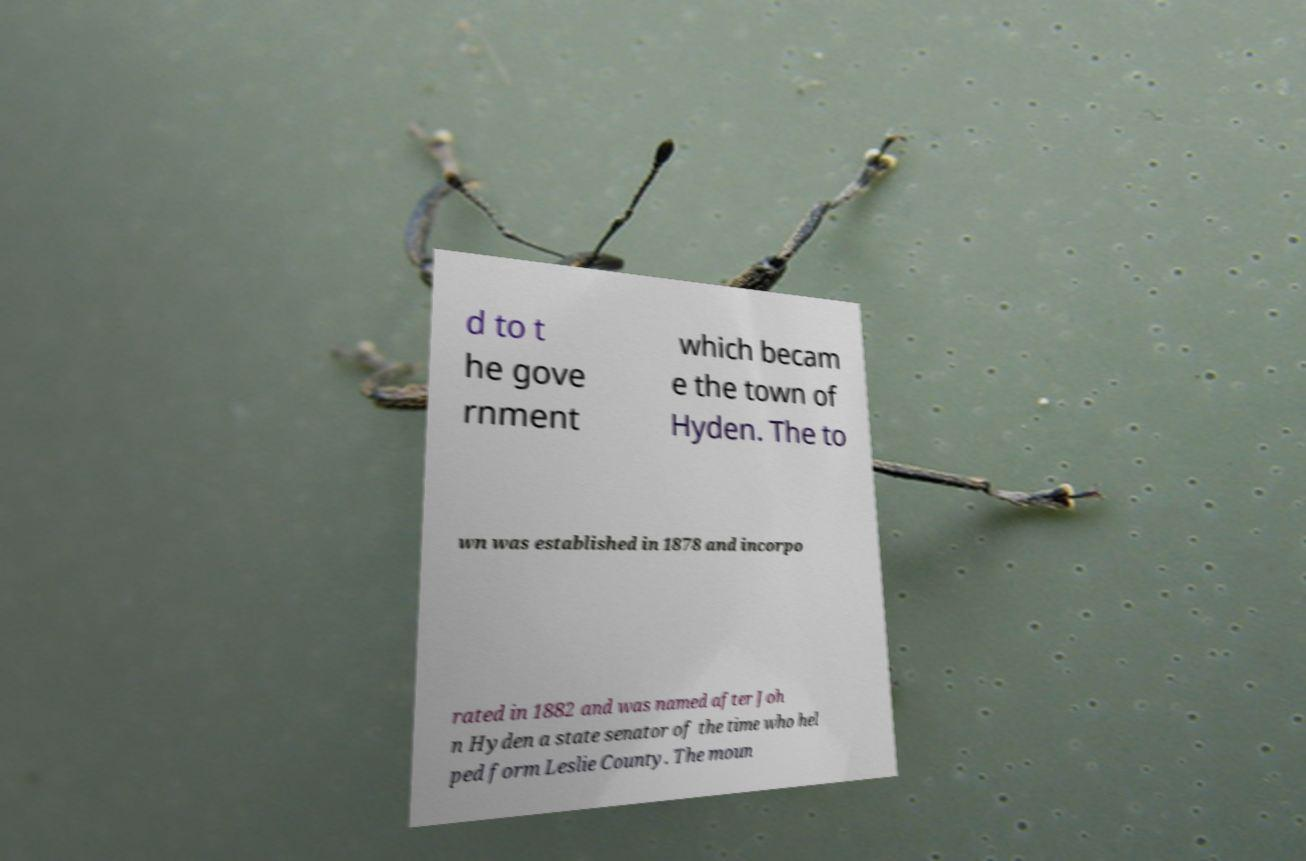Please read and relay the text visible in this image. What does it say? d to t he gove rnment which becam e the town of Hyden. The to wn was established in 1878 and incorpo rated in 1882 and was named after Joh n Hyden a state senator of the time who hel ped form Leslie County. The moun 